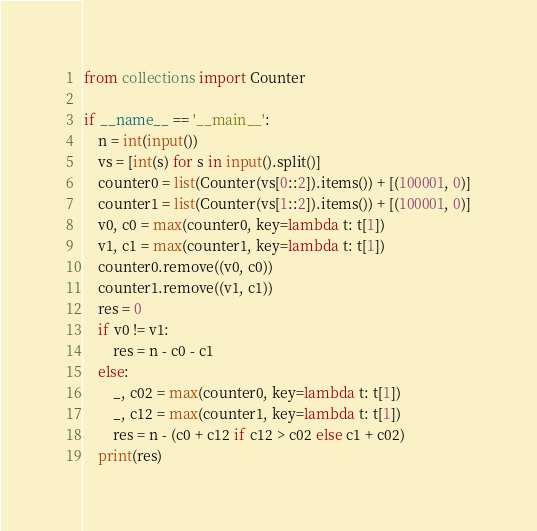Convert code to text. <code><loc_0><loc_0><loc_500><loc_500><_Python_>from collections import Counter

if __name__ == '__main__':
    n = int(input())
    vs = [int(s) for s in input().split()]
    counter0 = list(Counter(vs[0::2]).items()) + [(100001, 0)]
    counter1 = list(Counter(vs[1::2]).items()) + [(100001, 0)]
    v0, c0 = max(counter0, key=lambda t: t[1])
    v1, c1 = max(counter1, key=lambda t: t[1])
    counter0.remove((v0, c0))
    counter1.remove((v1, c1))
    res = 0
    if v0 != v1:
        res = n - c0 - c1
    else:
        _, c02 = max(counter0, key=lambda t: t[1])
        _, c12 = max(counter1, key=lambda t: t[1])
        res = n - (c0 + c12 if c12 > c02 else c1 + c02)
    print(res)
</code> 